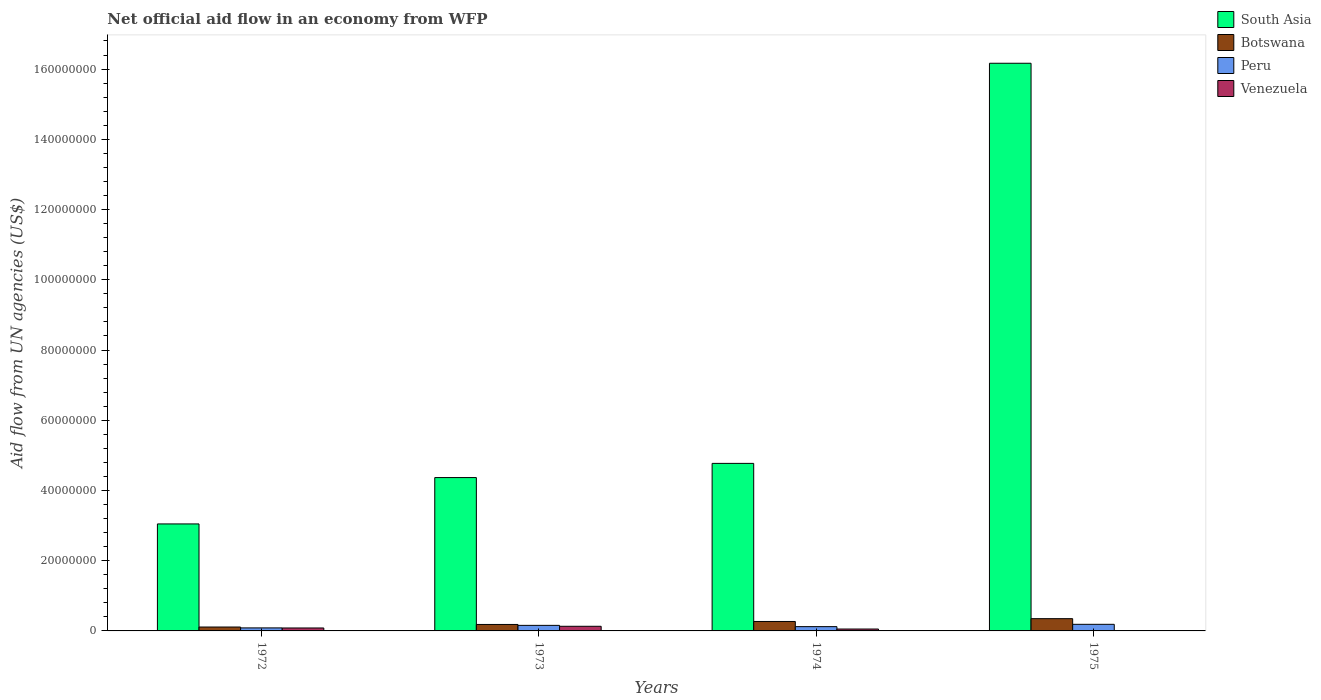How many bars are there on the 4th tick from the left?
Give a very brief answer. 4. How many bars are there on the 1st tick from the right?
Your answer should be very brief. 4. What is the label of the 2nd group of bars from the left?
Offer a very short reply. 1973. In how many cases, is the number of bars for a given year not equal to the number of legend labels?
Your answer should be compact. 0. What is the net official aid flow in Venezuela in 1972?
Ensure brevity in your answer.  8.40e+05. Across all years, what is the maximum net official aid flow in Venezuela?
Your answer should be compact. 1.32e+06. In which year was the net official aid flow in Venezuela maximum?
Keep it short and to the point. 1973. In which year was the net official aid flow in South Asia minimum?
Offer a very short reply. 1972. What is the total net official aid flow in Peru in the graph?
Keep it short and to the point. 5.54e+06. What is the difference between the net official aid flow in Venezuela in 1973 and that in 1975?
Your response must be concise. 1.26e+06. What is the average net official aid flow in South Asia per year?
Ensure brevity in your answer.  7.09e+07. In the year 1973, what is the difference between the net official aid flow in South Asia and net official aid flow in Venezuela?
Your answer should be very brief. 4.24e+07. What is the ratio of the net official aid flow in Botswana in 1972 to that in 1974?
Offer a terse response. 0.41. What is the difference between the highest and the lowest net official aid flow in South Asia?
Your answer should be compact. 1.31e+08. In how many years, is the net official aid flow in Venezuela greater than the average net official aid flow in Venezuela taken over all years?
Your answer should be compact. 2. Is it the case that in every year, the sum of the net official aid flow in Venezuela and net official aid flow in Peru is greater than the sum of net official aid flow in Botswana and net official aid flow in South Asia?
Keep it short and to the point. Yes. What does the 3rd bar from the left in 1972 represents?
Offer a very short reply. Peru. What does the 3rd bar from the right in 1972 represents?
Provide a succinct answer. Botswana. Is it the case that in every year, the sum of the net official aid flow in South Asia and net official aid flow in Venezuela is greater than the net official aid flow in Botswana?
Provide a short and direct response. Yes. How many bars are there?
Ensure brevity in your answer.  16. Does the graph contain any zero values?
Offer a very short reply. No. How many legend labels are there?
Make the answer very short. 4. How are the legend labels stacked?
Your response must be concise. Vertical. What is the title of the graph?
Offer a terse response. Net official aid flow in an economy from WFP. Does "Kenya" appear as one of the legend labels in the graph?
Offer a very short reply. No. What is the label or title of the Y-axis?
Provide a succinct answer. Aid flow from UN agencies (US$). What is the Aid flow from UN agencies (US$) of South Asia in 1972?
Provide a succinct answer. 3.05e+07. What is the Aid flow from UN agencies (US$) in Botswana in 1972?
Offer a very short reply. 1.11e+06. What is the Aid flow from UN agencies (US$) of Peru in 1972?
Provide a succinct answer. 8.60e+05. What is the Aid flow from UN agencies (US$) of Venezuela in 1972?
Keep it short and to the point. 8.40e+05. What is the Aid flow from UN agencies (US$) of South Asia in 1973?
Your response must be concise. 4.37e+07. What is the Aid flow from UN agencies (US$) of Botswana in 1973?
Ensure brevity in your answer.  1.84e+06. What is the Aid flow from UN agencies (US$) in Peru in 1973?
Your response must be concise. 1.58e+06. What is the Aid flow from UN agencies (US$) of Venezuela in 1973?
Provide a succinct answer. 1.32e+06. What is the Aid flow from UN agencies (US$) in South Asia in 1974?
Provide a succinct answer. 4.77e+07. What is the Aid flow from UN agencies (US$) in Botswana in 1974?
Provide a succinct answer. 2.69e+06. What is the Aid flow from UN agencies (US$) of Peru in 1974?
Keep it short and to the point. 1.22e+06. What is the Aid flow from UN agencies (US$) of Venezuela in 1974?
Give a very brief answer. 5.40e+05. What is the Aid flow from UN agencies (US$) in South Asia in 1975?
Offer a very short reply. 1.62e+08. What is the Aid flow from UN agencies (US$) in Botswana in 1975?
Ensure brevity in your answer.  3.49e+06. What is the Aid flow from UN agencies (US$) of Peru in 1975?
Ensure brevity in your answer.  1.88e+06. What is the Aid flow from UN agencies (US$) of Venezuela in 1975?
Your response must be concise. 6.00e+04. Across all years, what is the maximum Aid flow from UN agencies (US$) in South Asia?
Provide a short and direct response. 1.62e+08. Across all years, what is the maximum Aid flow from UN agencies (US$) in Botswana?
Your answer should be compact. 3.49e+06. Across all years, what is the maximum Aid flow from UN agencies (US$) in Peru?
Offer a terse response. 1.88e+06. Across all years, what is the maximum Aid flow from UN agencies (US$) in Venezuela?
Ensure brevity in your answer.  1.32e+06. Across all years, what is the minimum Aid flow from UN agencies (US$) in South Asia?
Provide a succinct answer. 3.05e+07. Across all years, what is the minimum Aid flow from UN agencies (US$) in Botswana?
Offer a very short reply. 1.11e+06. Across all years, what is the minimum Aid flow from UN agencies (US$) in Peru?
Provide a short and direct response. 8.60e+05. Across all years, what is the minimum Aid flow from UN agencies (US$) of Venezuela?
Give a very brief answer. 6.00e+04. What is the total Aid flow from UN agencies (US$) of South Asia in the graph?
Your answer should be compact. 2.84e+08. What is the total Aid flow from UN agencies (US$) in Botswana in the graph?
Give a very brief answer. 9.13e+06. What is the total Aid flow from UN agencies (US$) in Peru in the graph?
Offer a very short reply. 5.54e+06. What is the total Aid flow from UN agencies (US$) of Venezuela in the graph?
Keep it short and to the point. 2.76e+06. What is the difference between the Aid flow from UN agencies (US$) of South Asia in 1972 and that in 1973?
Make the answer very short. -1.32e+07. What is the difference between the Aid flow from UN agencies (US$) of Botswana in 1972 and that in 1973?
Give a very brief answer. -7.30e+05. What is the difference between the Aid flow from UN agencies (US$) in Peru in 1972 and that in 1973?
Ensure brevity in your answer.  -7.20e+05. What is the difference between the Aid flow from UN agencies (US$) in Venezuela in 1972 and that in 1973?
Give a very brief answer. -4.80e+05. What is the difference between the Aid flow from UN agencies (US$) of South Asia in 1972 and that in 1974?
Provide a short and direct response. -1.72e+07. What is the difference between the Aid flow from UN agencies (US$) in Botswana in 1972 and that in 1974?
Ensure brevity in your answer.  -1.58e+06. What is the difference between the Aid flow from UN agencies (US$) in Peru in 1972 and that in 1974?
Offer a very short reply. -3.60e+05. What is the difference between the Aid flow from UN agencies (US$) of Venezuela in 1972 and that in 1974?
Provide a short and direct response. 3.00e+05. What is the difference between the Aid flow from UN agencies (US$) in South Asia in 1972 and that in 1975?
Make the answer very short. -1.31e+08. What is the difference between the Aid flow from UN agencies (US$) in Botswana in 1972 and that in 1975?
Offer a very short reply. -2.38e+06. What is the difference between the Aid flow from UN agencies (US$) in Peru in 1972 and that in 1975?
Offer a very short reply. -1.02e+06. What is the difference between the Aid flow from UN agencies (US$) of Venezuela in 1972 and that in 1975?
Ensure brevity in your answer.  7.80e+05. What is the difference between the Aid flow from UN agencies (US$) in South Asia in 1973 and that in 1974?
Provide a short and direct response. -4.04e+06. What is the difference between the Aid flow from UN agencies (US$) in Botswana in 1973 and that in 1974?
Ensure brevity in your answer.  -8.50e+05. What is the difference between the Aid flow from UN agencies (US$) in Peru in 1973 and that in 1974?
Offer a terse response. 3.60e+05. What is the difference between the Aid flow from UN agencies (US$) in Venezuela in 1973 and that in 1974?
Your response must be concise. 7.80e+05. What is the difference between the Aid flow from UN agencies (US$) in South Asia in 1973 and that in 1975?
Your answer should be very brief. -1.18e+08. What is the difference between the Aid flow from UN agencies (US$) of Botswana in 1973 and that in 1975?
Give a very brief answer. -1.65e+06. What is the difference between the Aid flow from UN agencies (US$) in Venezuela in 1973 and that in 1975?
Keep it short and to the point. 1.26e+06. What is the difference between the Aid flow from UN agencies (US$) in South Asia in 1974 and that in 1975?
Your answer should be compact. -1.14e+08. What is the difference between the Aid flow from UN agencies (US$) of Botswana in 1974 and that in 1975?
Your answer should be compact. -8.00e+05. What is the difference between the Aid flow from UN agencies (US$) of Peru in 1974 and that in 1975?
Ensure brevity in your answer.  -6.60e+05. What is the difference between the Aid flow from UN agencies (US$) of Venezuela in 1974 and that in 1975?
Provide a succinct answer. 4.80e+05. What is the difference between the Aid flow from UN agencies (US$) of South Asia in 1972 and the Aid flow from UN agencies (US$) of Botswana in 1973?
Your answer should be very brief. 2.86e+07. What is the difference between the Aid flow from UN agencies (US$) in South Asia in 1972 and the Aid flow from UN agencies (US$) in Peru in 1973?
Your answer should be compact. 2.89e+07. What is the difference between the Aid flow from UN agencies (US$) of South Asia in 1972 and the Aid flow from UN agencies (US$) of Venezuela in 1973?
Your response must be concise. 2.92e+07. What is the difference between the Aid flow from UN agencies (US$) of Botswana in 1972 and the Aid flow from UN agencies (US$) of Peru in 1973?
Ensure brevity in your answer.  -4.70e+05. What is the difference between the Aid flow from UN agencies (US$) in Botswana in 1972 and the Aid flow from UN agencies (US$) in Venezuela in 1973?
Give a very brief answer. -2.10e+05. What is the difference between the Aid flow from UN agencies (US$) in Peru in 1972 and the Aid flow from UN agencies (US$) in Venezuela in 1973?
Offer a very short reply. -4.60e+05. What is the difference between the Aid flow from UN agencies (US$) of South Asia in 1972 and the Aid flow from UN agencies (US$) of Botswana in 1974?
Your answer should be very brief. 2.78e+07. What is the difference between the Aid flow from UN agencies (US$) of South Asia in 1972 and the Aid flow from UN agencies (US$) of Peru in 1974?
Ensure brevity in your answer.  2.92e+07. What is the difference between the Aid flow from UN agencies (US$) of South Asia in 1972 and the Aid flow from UN agencies (US$) of Venezuela in 1974?
Ensure brevity in your answer.  2.99e+07. What is the difference between the Aid flow from UN agencies (US$) in Botswana in 1972 and the Aid flow from UN agencies (US$) in Peru in 1974?
Provide a succinct answer. -1.10e+05. What is the difference between the Aid flow from UN agencies (US$) in Botswana in 1972 and the Aid flow from UN agencies (US$) in Venezuela in 1974?
Keep it short and to the point. 5.70e+05. What is the difference between the Aid flow from UN agencies (US$) of South Asia in 1972 and the Aid flow from UN agencies (US$) of Botswana in 1975?
Your answer should be compact. 2.70e+07. What is the difference between the Aid flow from UN agencies (US$) in South Asia in 1972 and the Aid flow from UN agencies (US$) in Peru in 1975?
Your response must be concise. 2.86e+07. What is the difference between the Aid flow from UN agencies (US$) of South Asia in 1972 and the Aid flow from UN agencies (US$) of Venezuela in 1975?
Ensure brevity in your answer.  3.04e+07. What is the difference between the Aid flow from UN agencies (US$) of Botswana in 1972 and the Aid flow from UN agencies (US$) of Peru in 1975?
Offer a terse response. -7.70e+05. What is the difference between the Aid flow from UN agencies (US$) of Botswana in 1972 and the Aid flow from UN agencies (US$) of Venezuela in 1975?
Offer a terse response. 1.05e+06. What is the difference between the Aid flow from UN agencies (US$) in South Asia in 1973 and the Aid flow from UN agencies (US$) in Botswana in 1974?
Give a very brief answer. 4.10e+07. What is the difference between the Aid flow from UN agencies (US$) of South Asia in 1973 and the Aid flow from UN agencies (US$) of Peru in 1974?
Provide a short and direct response. 4.24e+07. What is the difference between the Aid flow from UN agencies (US$) of South Asia in 1973 and the Aid flow from UN agencies (US$) of Venezuela in 1974?
Your answer should be compact. 4.31e+07. What is the difference between the Aid flow from UN agencies (US$) of Botswana in 1973 and the Aid flow from UN agencies (US$) of Peru in 1974?
Keep it short and to the point. 6.20e+05. What is the difference between the Aid flow from UN agencies (US$) of Botswana in 1973 and the Aid flow from UN agencies (US$) of Venezuela in 1974?
Keep it short and to the point. 1.30e+06. What is the difference between the Aid flow from UN agencies (US$) of Peru in 1973 and the Aid flow from UN agencies (US$) of Venezuela in 1974?
Your answer should be very brief. 1.04e+06. What is the difference between the Aid flow from UN agencies (US$) in South Asia in 1973 and the Aid flow from UN agencies (US$) in Botswana in 1975?
Provide a short and direct response. 4.02e+07. What is the difference between the Aid flow from UN agencies (US$) in South Asia in 1973 and the Aid flow from UN agencies (US$) in Peru in 1975?
Make the answer very short. 4.18e+07. What is the difference between the Aid flow from UN agencies (US$) of South Asia in 1973 and the Aid flow from UN agencies (US$) of Venezuela in 1975?
Your response must be concise. 4.36e+07. What is the difference between the Aid flow from UN agencies (US$) of Botswana in 1973 and the Aid flow from UN agencies (US$) of Venezuela in 1975?
Provide a succinct answer. 1.78e+06. What is the difference between the Aid flow from UN agencies (US$) of Peru in 1973 and the Aid flow from UN agencies (US$) of Venezuela in 1975?
Provide a succinct answer. 1.52e+06. What is the difference between the Aid flow from UN agencies (US$) in South Asia in 1974 and the Aid flow from UN agencies (US$) in Botswana in 1975?
Offer a terse response. 4.42e+07. What is the difference between the Aid flow from UN agencies (US$) of South Asia in 1974 and the Aid flow from UN agencies (US$) of Peru in 1975?
Your answer should be compact. 4.58e+07. What is the difference between the Aid flow from UN agencies (US$) in South Asia in 1974 and the Aid flow from UN agencies (US$) in Venezuela in 1975?
Keep it short and to the point. 4.76e+07. What is the difference between the Aid flow from UN agencies (US$) of Botswana in 1974 and the Aid flow from UN agencies (US$) of Peru in 1975?
Ensure brevity in your answer.  8.10e+05. What is the difference between the Aid flow from UN agencies (US$) of Botswana in 1974 and the Aid flow from UN agencies (US$) of Venezuela in 1975?
Ensure brevity in your answer.  2.63e+06. What is the difference between the Aid flow from UN agencies (US$) of Peru in 1974 and the Aid flow from UN agencies (US$) of Venezuela in 1975?
Ensure brevity in your answer.  1.16e+06. What is the average Aid flow from UN agencies (US$) of South Asia per year?
Provide a short and direct response. 7.09e+07. What is the average Aid flow from UN agencies (US$) of Botswana per year?
Your answer should be compact. 2.28e+06. What is the average Aid flow from UN agencies (US$) of Peru per year?
Your answer should be very brief. 1.38e+06. What is the average Aid flow from UN agencies (US$) of Venezuela per year?
Offer a very short reply. 6.90e+05. In the year 1972, what is the difference between the Aid flow from UN agencies (US$) in South Asia and Aid flow from UN agencies (US$) in Botswana?
Ensure brevity in your answer.  2.94e+07. In the year 1972, what is the difference between the Aid flow from UN agencies (US$) in South Asia and Aid flow from UN agencies (US$) in Peru?
Provide a short and direct response. 2.96e+07. In the year 1972, what is the difference between the Aid flow from UN agencies (US$) of South Asia and Aid flow from UN agencies (US$) of Venezuela?
Your response must be concise. 2.96e+07. In the year 1972, what is the difference between the Aid flow from UN agencies (US$) of Botswana and Aid flow from UN agencies (US$) of Peru?
Keep it short and to the point. 2.50e+05. In the year 1972, what is the difference between the Aid flow from UN agencies (US$) in Botswana and Aid flow from UN agencies (US$) in Venezuela?
Offer a very short reply. 2.70e+05. In the year 1972, what is the difference between the Aid flow from UN agencies (US$) in Peru and Aid flow from UN agencies (US$) in Venezuela?
Provide a succinct answer. 2.00e+04. In the year 1973, what is the difference between the Aid flow from UN agencies (US$) in South Asia and Aid flow from UN agencies (US$) in Botswana?
Your answer should be compact. 4.18e+07. In the year 1973, what is the difference between the Aid flow from UN agencies (US$) in South Asia and Aid flow from UN agencies (US$) in Peru?
Provide a short and direct response. 4.21e+07. In the year 1973, what is the difference between the Aid flow from UN agencies (US$) of South Asia and Aid flow from UN agencies (US$) of Venezuela?
Provide a succinct answer. 4.24e+07. In the year 1973, what is the difference between the Aid flow from UN agencies (US$) of Botswana and Aid flow from UN agencies (US$) of Venezuela?
Offer a very short reply. 5.20e+05. In the year 1974, what is the difference between the Aid flow from UN agencies (US$) in South Asia and Aid flow from UN agencies (US$) in Botswana?
Offer a very short reply. 4.50e+07. In the year 1974, what is the difference between the Aid flow from UN agencies (US$) in South Asia and Aid flow from UN agencies (US$) in Peru?
Keep it short and to the point. 4.65e+07. In the year 1974, what is the difference between the Aid flow from UN agencies (US$) in South Asia and Aid flow from UN agencies (US$) in Venezuela?
Give a very brief answer. 4.72e+07. In the year 1974, what is the difference between the Aid flow from UN agencies (US$) in Botswana and Aid flow from UN agencies (US$) in Peru?
Keep it short and to the point. 1.47e+06. In the year 1974, what is the difference between the Aid flow from UN agencies (US$) in Botswana and Aid flow from UN agencies (US$) in Venezuela?
Offer a very short reply. 2.15e+06. In the year 1974, what is the difference between the Aid flow from UN agencies (US$) in Peru and Aid flow from UN agencies (US$) in Venezuela?
Keep it short and to the point. 6.80e+05. In the year 1975, what is the difference between the Aid flow from UN agencies (US$) in South Asia and Aid flow from UN agencies (US$) in Botswana?
Your answer should be compact. 1.58e+08. In the year 1975, what is the difference between the Aid flow from UN agencies (US$) of South Asia and Aid flow from UN agencies (US$) of Peru?
Keep it short and to the point. 1.60e+08. In the year 1975, what is the difference between the Aid flow from UN agencies (US$) of South Asia and Aid flow from UN agencies (US$) of Venezuela?
Ensure brevity in your answer.  1.62e+08. In the year 1975, what is the difference between the Aid flow from UN agencies (US$) of Botswana and Aid flow from UN agencies (US$) of Peru?
Provide a succinct answer. 1.61e+06. In the year 1975, what is the difference between the Aid flow from UN agencies (US$) of Botswana and Aid flow from UN agencies (US$) of Venezuela?
Offer a terse response. 3.43e+06. In the year 1975, what is the difference between the Aid flow from UN agencies (US$) in Peru and Aid flow from UN agencies (US$) in Venezuela?
Make the answer very short. 1.82e+06. What is the ratio of the Aid flow from UN agencies (US$) of South Asia in 1972 to that in 1973?
Your answer should be compact. 0.7. What is the ratio of the Aid flow from UN agencies (US$) of Botswana in 1972 to that in 1973?
Ensure brevity in your answer.  0.6. What is the ratio of the Aid flow from UN agencies (US$) in Peru in 1972 to that in 1973?
Make the answer very short. 0.54. What is the ratio of the Aid flow from UN agencies (US$) of Venezuela in 1972 to that in 1973?
Offer a terse response. 0.64. What is the ratio of the Aid flow from UN agencies (US$) in South Asia in 1972 to that in 1974?
Provide a succinct answer. 0.64. What is the ratio of the Aid flow from UN agencies (US$) of Botswana in 1972 to that in 1974?
Offer a very short reply. 0.41. What is the ratio of the Aid flow from UN agencies (US$) of Peru in 1972 to that in 1974?
Give a very brief answer. 0.7. What is the ratio of the Aid flow from UN agencies (US$) in Venezuela in 1972 to that in 1974?
Offer a terse response. 1.56. What is the ratio of the Aid flow from UN agencies (US$) of South Asia in 1972 to that in 1975?
Provide a short and direct response. 0.19. What is the ratio of the Aid flow from UN agencies (US$) of Botswana in 1972 to that in 1975?
Provide a short and direct response. 0.32. What is the ratio of the Aid flow from UN agencies (US$) of Peru in 1972 to that in 1975?
Your response must be concise. 0.46. What is the ratio of the Aid flow from UN agencies (US$) in Venezuela in 1972 to that in 1975?
Offer a very short reply. 14. What is the ratio of the Aid flow from UN agencies (US$) in South Asia in 1973 to that in 1974?
Give a very brief answer. 0.92. What is the ratio of the Aid flow from UN agencies (US$) in Botswana in 1973 to that in 1974?
Provide a short and direct response. 0.68. What is the ratio of the Aid flow from UN agencies (US$) in Peru in 1973 to that in 1974?
Offer a terse response. 1.3. What is the ratio of the Aid flow from UN agencies (US$) of Venezuela in 1973 to that in 1974?
Provide a short and direct response. 2.44. What is the ratio of the Aid flow from UN agencies (US$) of South Asia in 1973 to that in 1975?
Your answer should be very brief. 0.27. What is the ratio of the Aid flow from UN agencies (US$) in Botswana in 1973 to that in 1975?
Your answer should be very brief. 0.53. What is the ratio of the Aid flow from UN agencies (US$) of Peru in 1973 to that in 1975?
Provide a short and direct response. 0.84. What is the ratio of the Aid flow from UN agencies (US$) in South Asia in 1974 to that in 1975?
Give a very brief answer. 0.3. What is the ratio of the Aid flow from UN agencies (US$) of Botswana in 1974 to that in 1975?
Provide a short and direct response. 0.77. What is the ratio of the Aid flow from UN agencies (US$) of Peru in 1974 to that in 1975?
Offer a terse response. 0.65. What is the ratio of the Aid flow from UN agencies (US$) of Venezuela in 1974 to that in 1975?
Make the answer very short. 9. What is the difference between the highest and the second highest Aid flow from UN agencies (US$) in South Asia?
Provide a succinct answer. 1.14e+08. What is the difference between the highest and the second highest Aid flow from UN agencies (US$) in Botswana?
Offer a very short reply. 8.00e+05. What is the difference between the highest and the second highest Aid flow from UN agencies (US$) of Venezuela?
Keep it short and to the point. 4.80e+05. What is the difference between the highest and the lowest Aid flow from UN agencies (US$) in South Asia?
Give a very brief answer. 1.31e+08. What is the difference between the highest and the lowest Aid flow from UN agencies (US$) of Botswana?
Make the answer very short. 2.38e+06. What is the difference between the highest and the lowest Aid flow from UN agencies (US$) in Peru?
Offer a terse response. 1.02e+06. What is the difference between the highest and the lowest Aid flow from UN agencies (US$) of Venezuela?
Make the answer very short. 1.26e+06. 